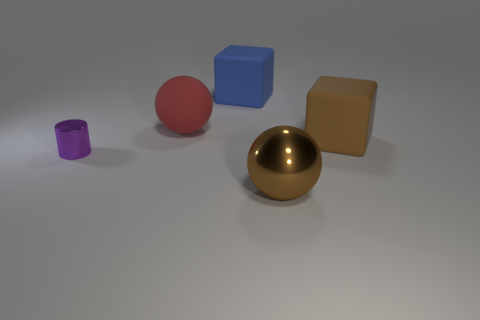Add 1 large cyan metal balls. How many objects exist? 6 Subtract all red spheres. How many spheres are left? 1 Subtract 0 brown cylinders. How many objects are left? 5 Subtract all cubes. How many objects are left? 3 Subtract 1 cylinders. How many cylinders are left? 0 Subtract all brown cylinders. Subtract all green balls. How many cylinders are left? 1 Subtract all purple blocks. How many red balls are left? 1 Subtract all red matte objects. Subtract all red objects. How many objects are left? 3 Add 1 big rubber blocks. How many big rubber blocks are left? 3 Add 1 red matte balls. How many red matte balls exist? 2 